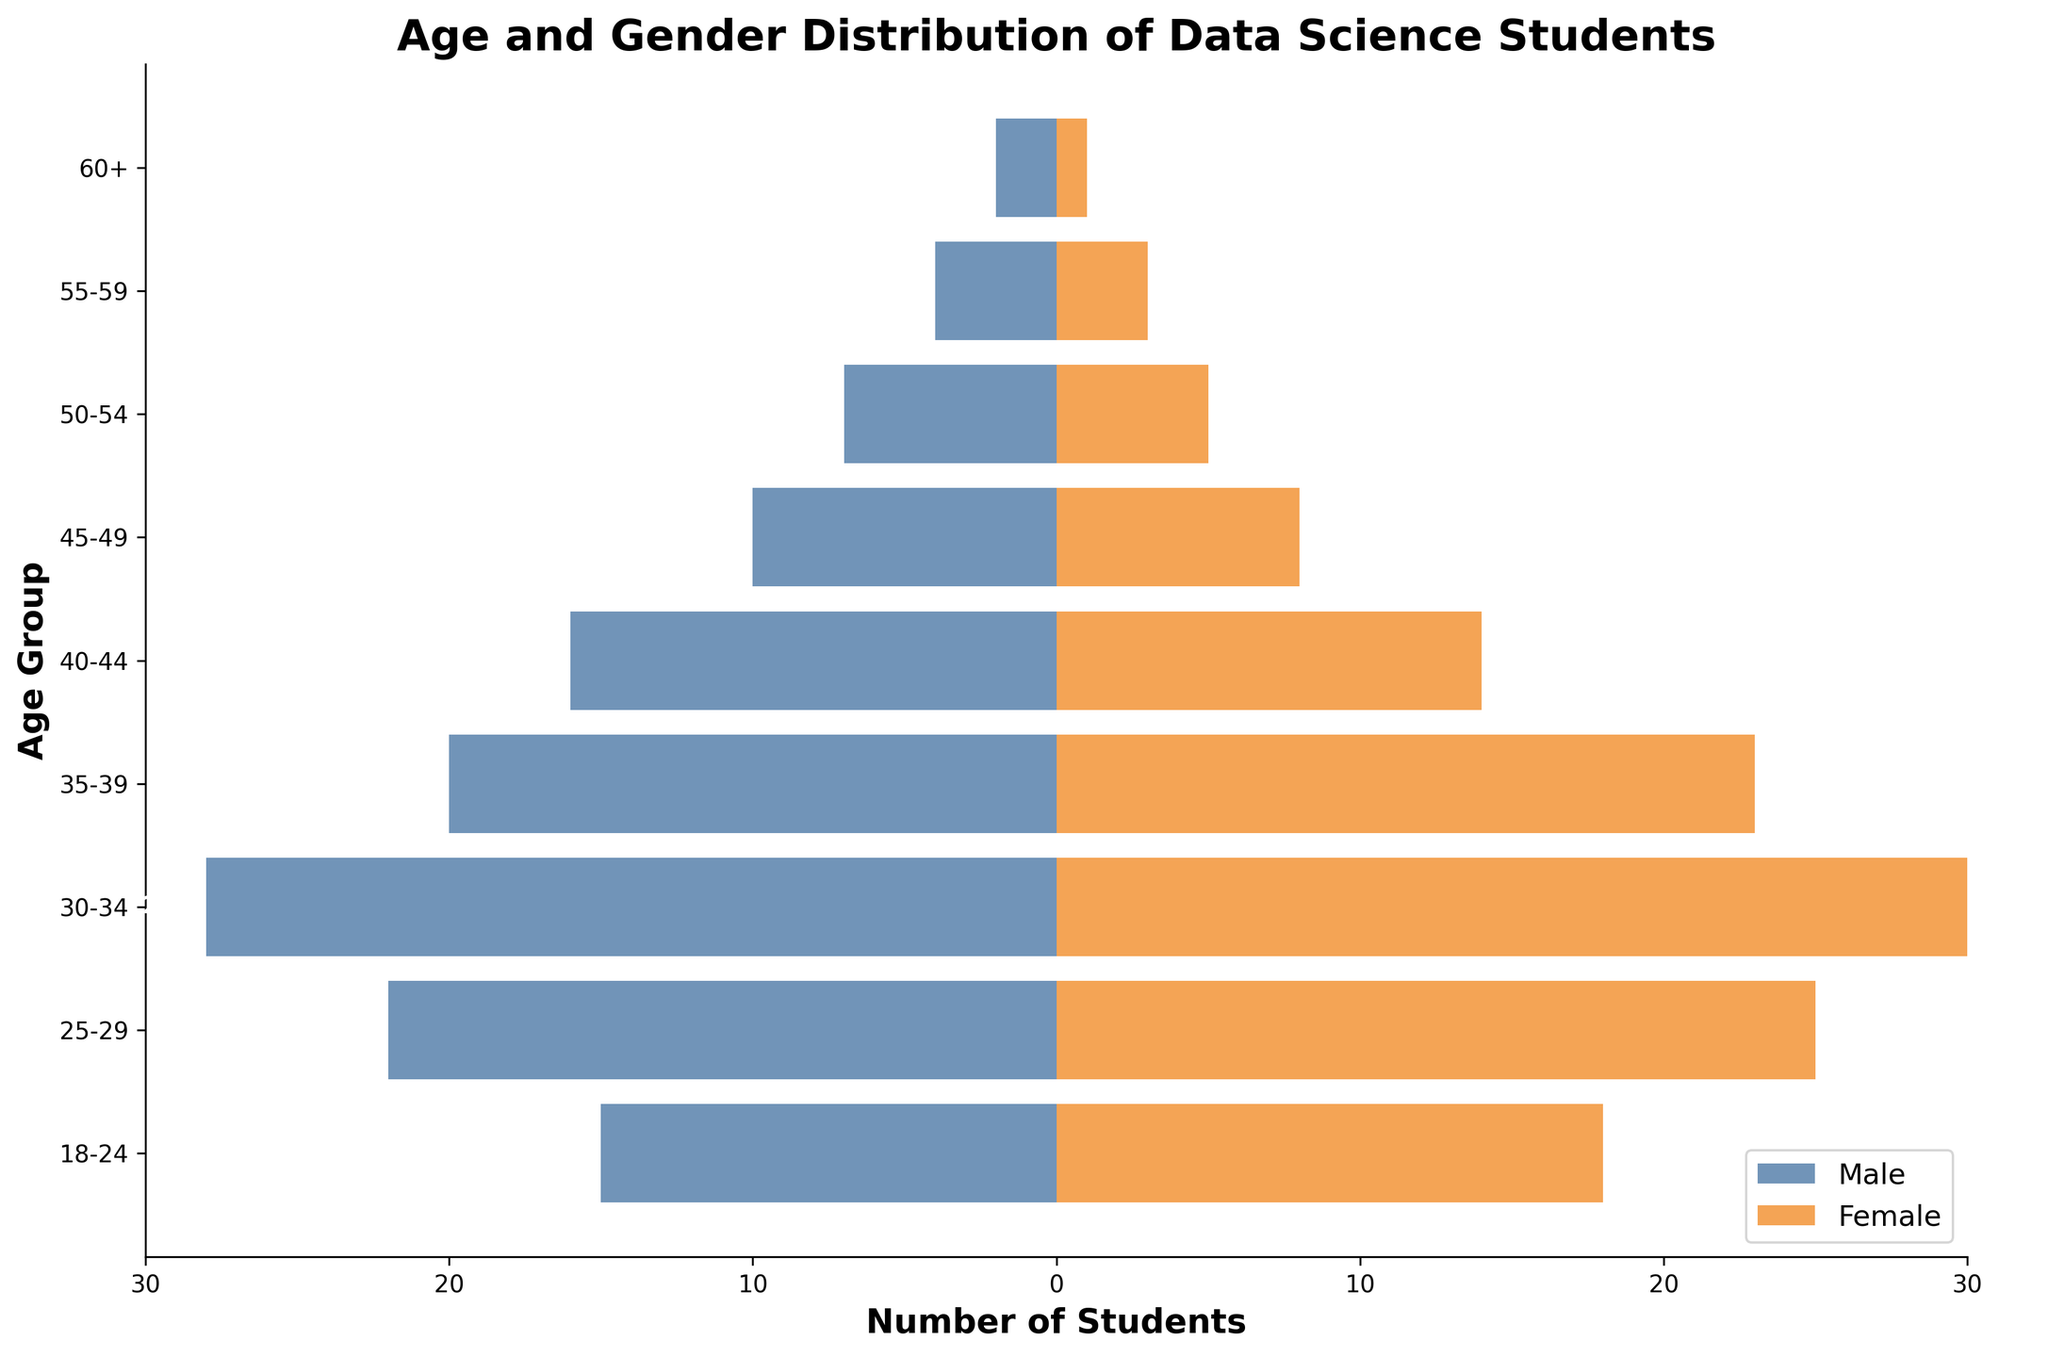What's the title of the plot? The title of the plot is placed at the top of the figure. It's usually descriptive of the data being represented.
Answer: Age and Gender Distribution of Data Science Students What are the two genders represented in the plot? The plot uses different bar colors to represent the two genders, typically found in the legend box.
Answer: Male and Female Which age group has the highest number of students? By examining the bar lengths, we can determine the age group with the most students, both male and female combined. The group with the longest bars will have the highest number.
Answer: 30-34 What is the total number of male students in the 25-29 and 30-34 age groups? Sum the male students in the 25-29 age group (22) with those in the 30-34 age group (28).
Answer: 50 In which age group is the number of female students greater than the number of male students? Compare the lengths of the orange bars (Female) and blue bars (Male) for each age group. Look for the group where the orange bar is longer.
Answer: 40-44 What is the overall gender ratio in the 18-24 age group? Divide the number of male students by the number of female students in the 18-24 age group to get the gender ratio.
Answer: 15:18 or approximately 0.83 What is the difference in the number of male and female students in the 30-34 age group? Subtract the number of male students from the number of female students in the 30-34 age group (30 - 28).
Answer: 2 Which age group has the smallest number of both male and female students combined? Examine each age group's male and female student counts, and find the group with the least combined sum.
Answer: 60+ What is the average number of students per age group? Calculate the total number of students, combining both genders for all age groups, then divide by the number of age groups.
Answer: Sum: 202, Age Groups: 9, Average: 202 / 9 ≈ 22.44 